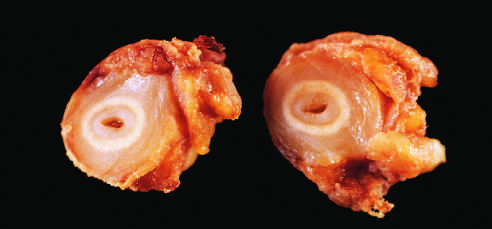do the white circles correspond to the original vessel wall?
Answer the question using a single word or phrase. Yes 